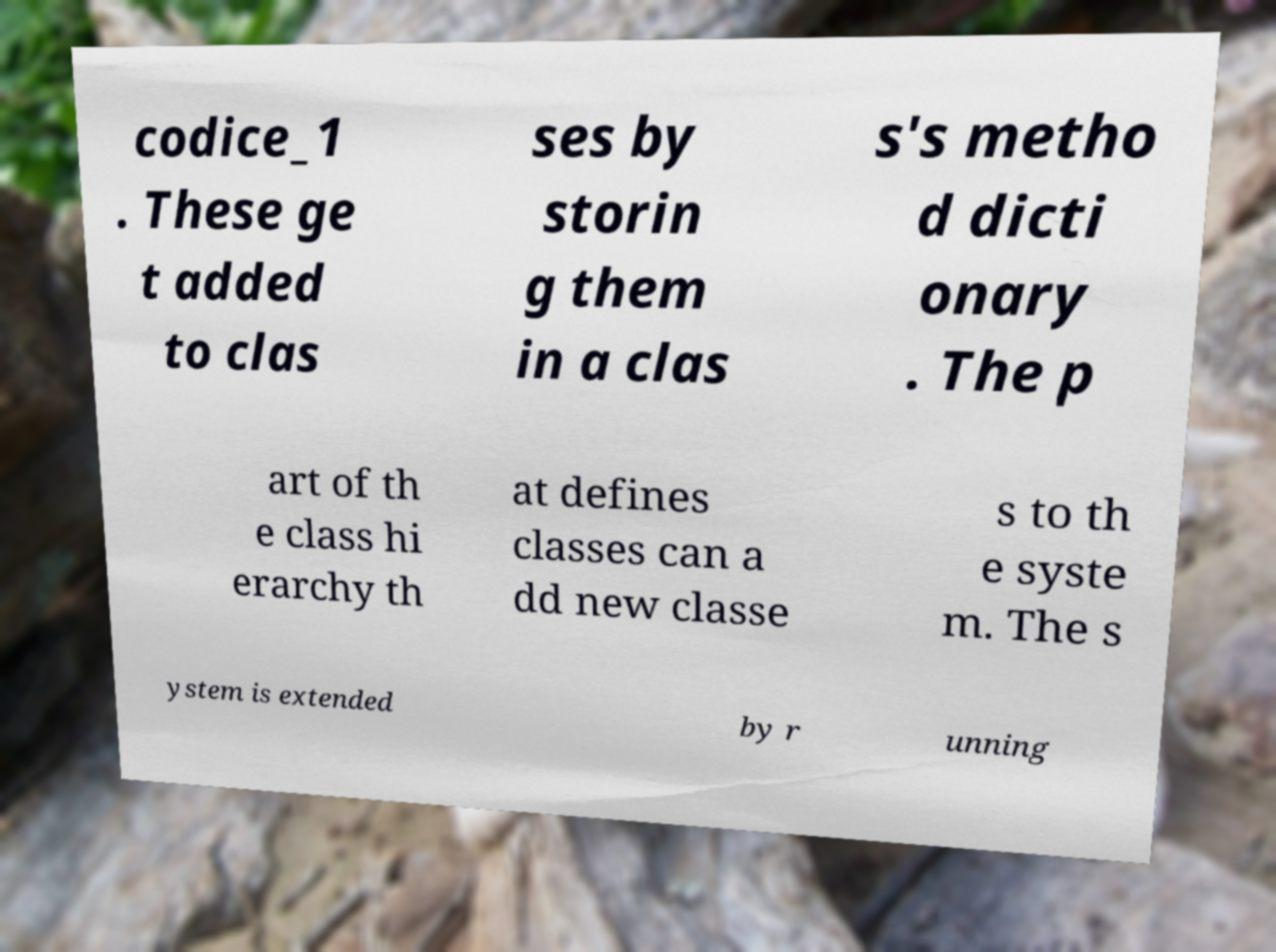Can you accurately transcribe the text from the provided image for me? codice_1 . These ge t added to clas ses by storin g them in a clas s's metho d dicti onary . The p art of th e class hi erarchy th at defines classes can a dd new classe s to th e syste m. The s ystem is extended by r unning 